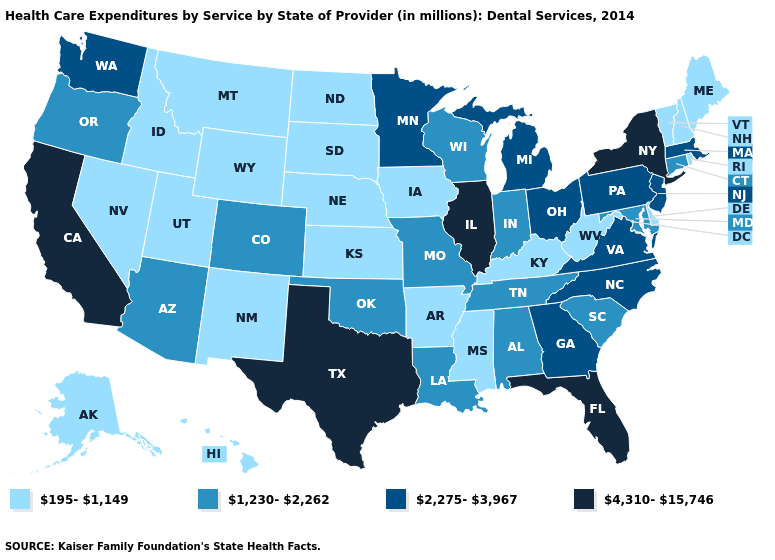What is the lowest value in the USA?
Be succinct. 195-1,149. Name the states that have a value in the range 4,310-15,746?
Write a very short answer. California, Florida, Illinois, New York, Texas. Which states have the highest value in the USA?
Keep it brief. California, Florida, Illinois, New York, Texas. Among the states that border Wisconsin , does Michigan have the lowest value?
Write a very short answer. No. What is the highest value in the MidWest ?
Short answer required. 4,310-15,746. Name the states that have a value in the range 1,230-2,262?
Concise answer only. Alabama, Arizona, Colorado, Connecticut, Indiana, Louisiana, Maryland, Missouri, Oklahoma, Oregon, South Carolina, Tennessee, Wisconsin. Does Texas have the same value as Minnesota?
Concise answer only. No. Which states have the lowest value in the USA?
Be succinct. Alaska, Arkansas, Delaware, Hawaii, Idaho, Iowa, Kansas, Kentucky, Maine, Mississippi, Montana, Nebraska, Nevada, New Hampshire, New Mexico, North Dakota, Rhode Island, South Dakota, Utah, Vermont, West Virginia, Wyoming. What is the lowest value in states that border Iowa?
Write a very short answer. 195-1,149. Is the legend a continuous bar?
Give a very brief answer. No. What is the value of Missouri?
Be succinct. 1,230-2,262. Name the states that have a value in the range 2,275-3,967?
Answer briefly. Georgia, Massachusetts, Michigan, Minnesota, New Jersey, North Carolina, Ohio, Pennsylvania, Virginia, Washington. Among the states that border Iowa , does Illinois have the highest value?
Short answer required. Yes. How many symbols are there in the legend?
Short answer required. 4. Among the states that border Montana , which have the lowest value?
Short answer required. Idaho, North Dakota, South Dakota, Wyoming. 